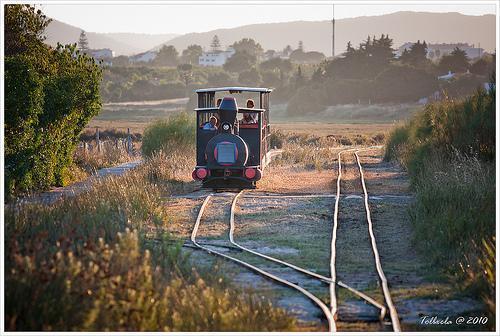How many trains are there?
Give a very brief answer. 1. How many red lights are on the front of the train?
Give a very brief answer. 2. 